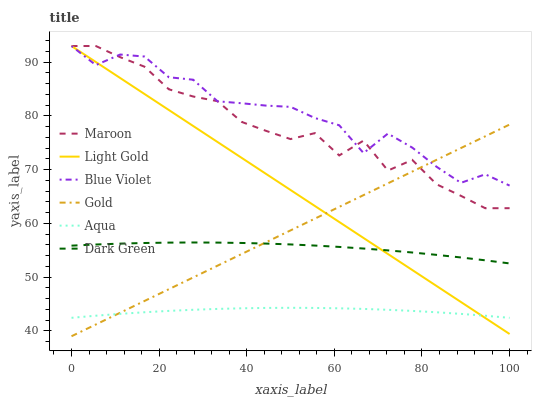Does Aqua have the minimum area under the curve?
Answer yes or no. Yes. Does Blue Violet have the maximum area under the curve?
Answer yes or no. Yes. Does Maroon have the minimum area under the curve?
Answer yes or no. No. Does Maroon have the maximum area under the curve?
Answer yes or no. No. Is Gold the smoothest?
Answer yes or no. Yes. Is Maroon the roughest?
Answer yes or no. Yes. Is Aqua the smoothest?
Answer yes or no. No. Is Aqua the roughest?
Answer yes or no. No. Does Gold have the lowest value?
Answer yes or no. Yes. Does Aqua have the lowest value?
Answer yes or no. No. Does Blue Violet have the highest value?
Answer yes or no. Yes. Does Aqua have the highest value?
Answer yes or no. No. Is Aqua less than Dark Green?
Answer yes or no. Yes. Is Maroon greater than Aqua?
Answer yes or no. Yes. Does Gold intersect Blue Violet?
Answer yes or no. Yes. Is Gold less than Blue Violet?
Answer yes or no. No. Is Gold greater than Blue Violet?
Answer yes or no. No. Does Aqua intersect Dark Green?
Answer yes or no. No. 